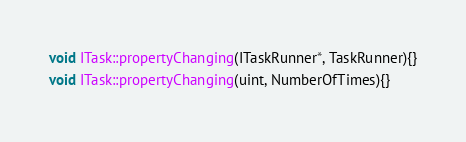Convert code to text. <code><loc_0><loc_0><loc_500><loc_500><_C++_>void ITask::propertyChanging(ITaskRunner*, TaskRunner){}
void ITask::propertyChanging(uint, NumberOfTimes){}</code> 